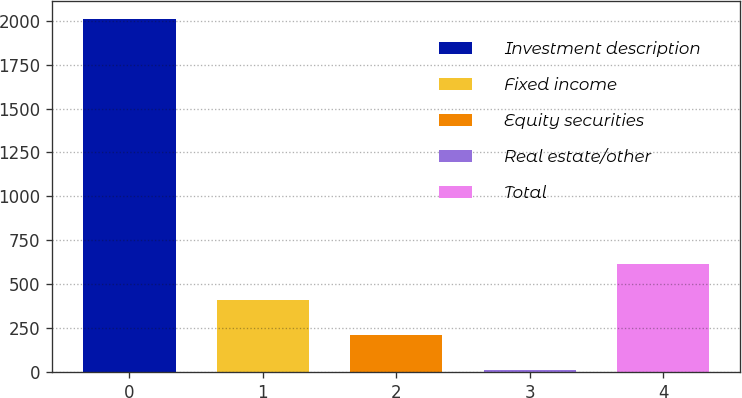Convert chart. <chart><loc_0><loc_0><loc_500><loc_500><bar_chart><fcel>Investment description<fcel>Fixed income<fcel>Equity securities<fcel>Real estate/other<fcel>Total<nl><fcel>2012<fcel>412.32<fcel>212.36<fcel>12.4<fcel>612.28<nl></chart> 